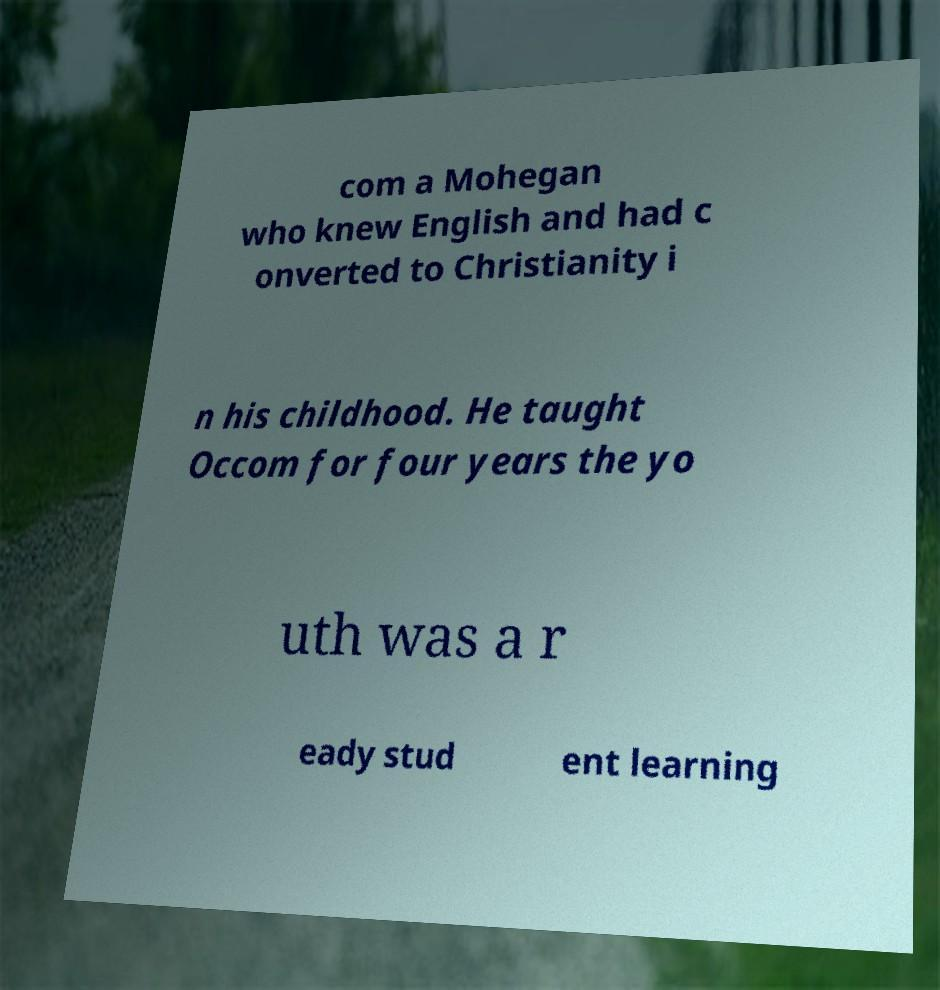Please read and relay the text visible in this image. What does it say? com a Mohegan who knew English and had c onverted to Christianity i n his childhood. He taught Occom for four years the yo uth was a r eady stud ent learning 